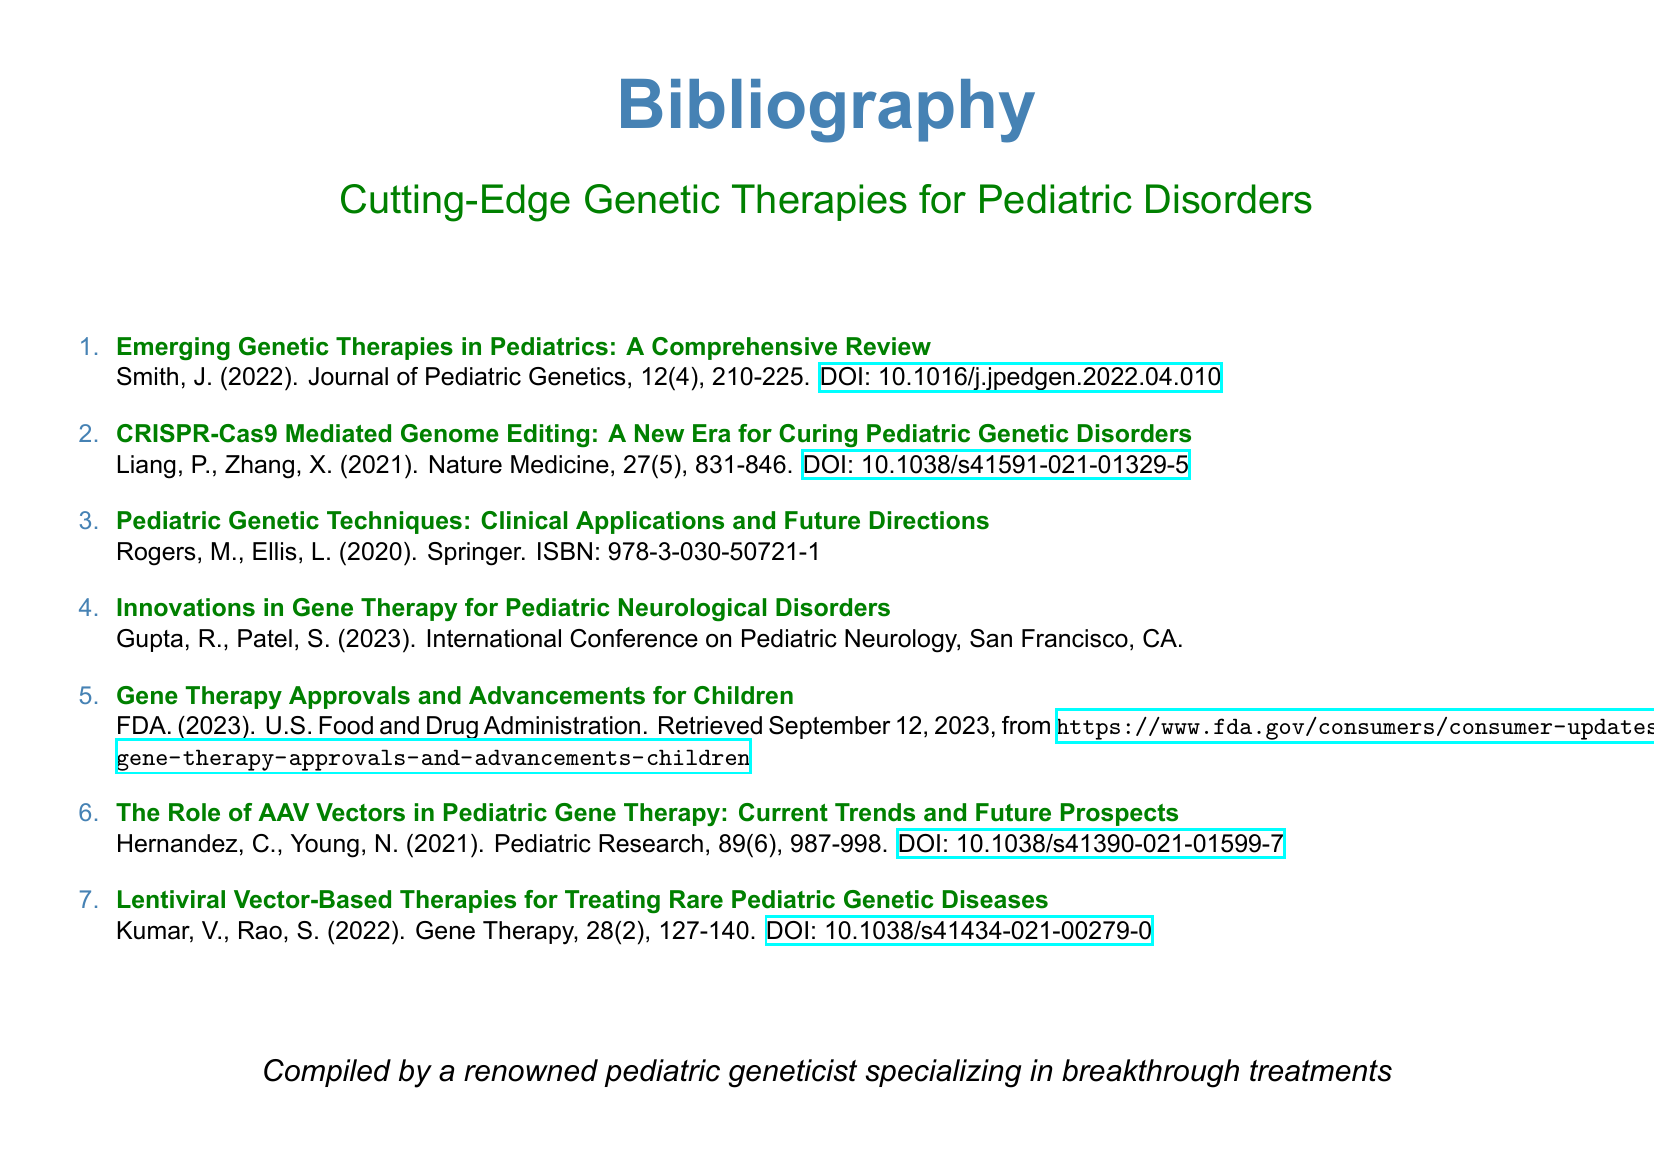what is the title of the document? The title of the document is mentioned at the top center.
Answer: Bibliography who is the author of the first entry? The author of the first entry is listed under the title.
Answer: Smith, J what year was the second entry published? The year of publication for the second entry is included with the citation.
Answer: 2021 which journal published the entry about AAV vectors? The journal name is part of the citation in the entry.
Answer: Pediatric Research how many entries are included in the bibliography? The total number of entries is represented by the list numbering.
Answer: 7 which genetic therapy technique is discussed in the fourth entry? The title of the fourth entry specifies the technique being discussed.
Answer: Gene Therapy what is the ISBN for the book listed in the third entry? The ISBN is provided in the citation of the third entry.
Answer: 978-3-030-50721-1 who compiled this bibliography? The contributor to the bibliography is noted at the bottom.
Answer: A renowned pediatric geneticist 